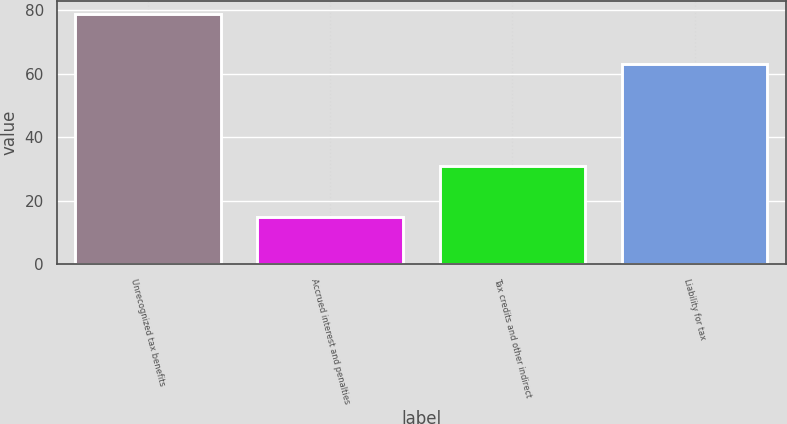<chart> <loc_0><loc_0><loc_500><loc_500><bar_chart><fcel>Unrecognized tax benefits<fcel>Accrued interest and penalties<fcel>Tax credits and other indirect<fcel>Liability for tax<nl><fcel>79<fcel>15<fcel>31<fcel>63<nl></chart> 